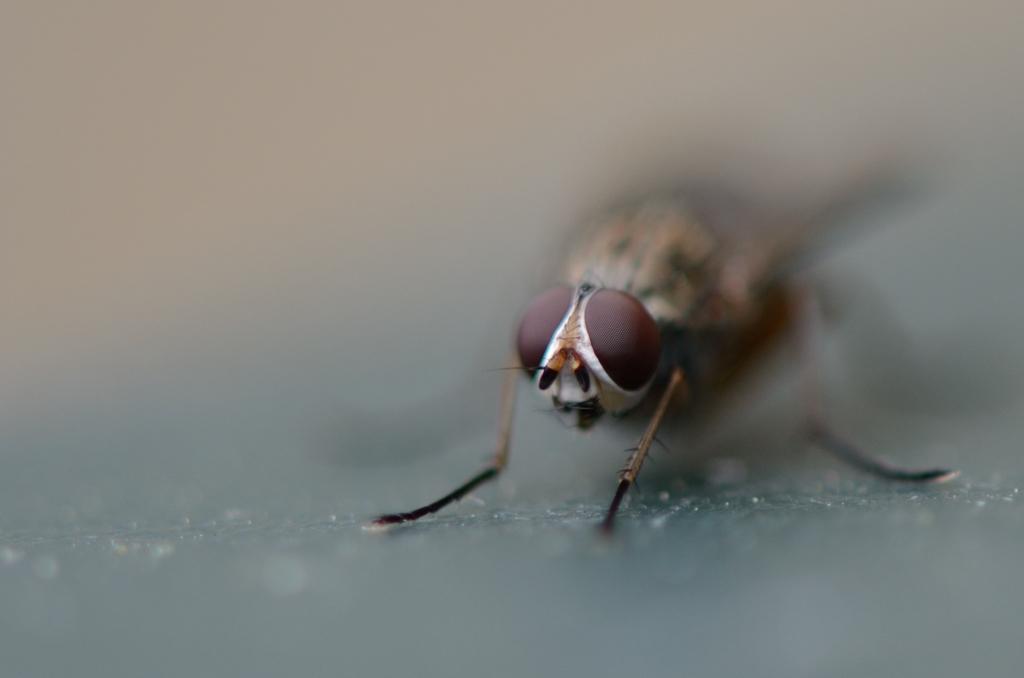Describe this image in one or two sentences. On the right side of this image there is a bee. The background is blurred. 